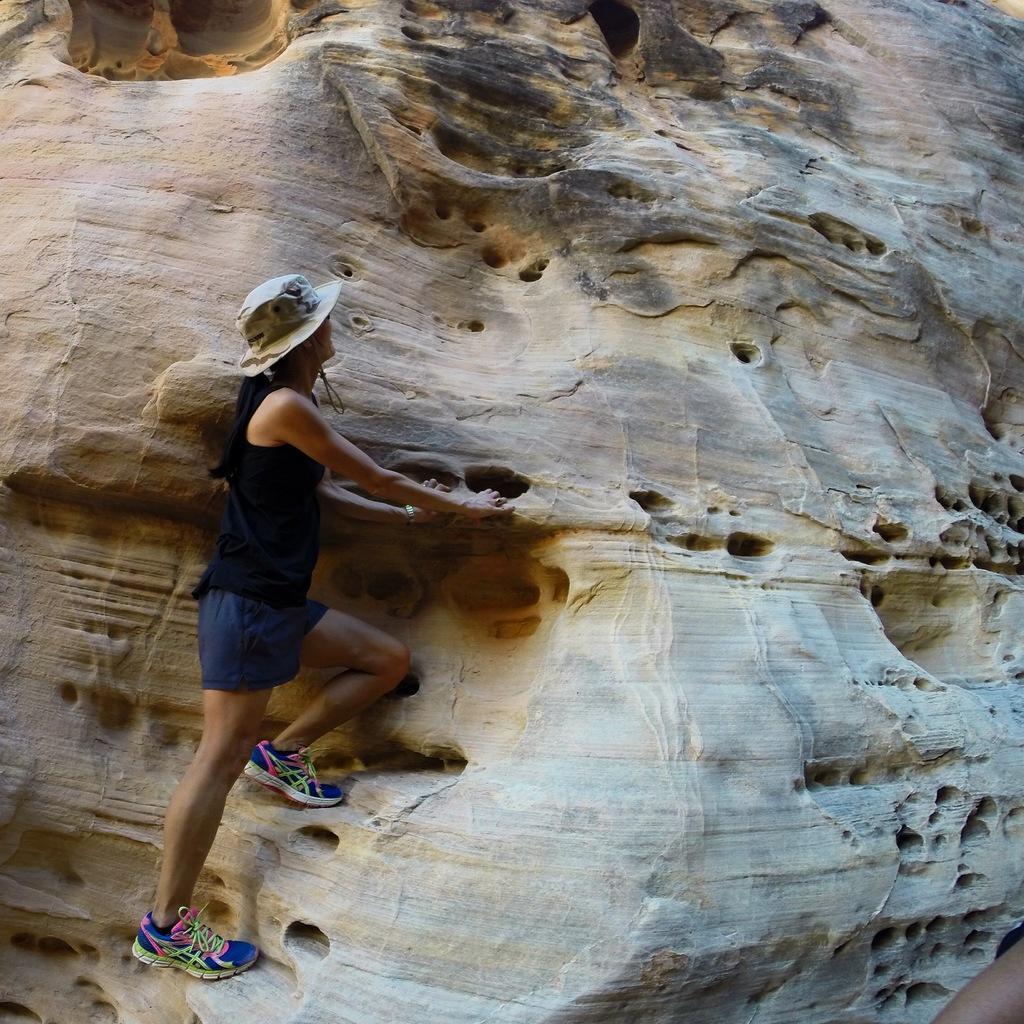In one or two sentences, can you explain what this image depicts? In this image we can see a person standing on a rock and the person is wearing a hat. 